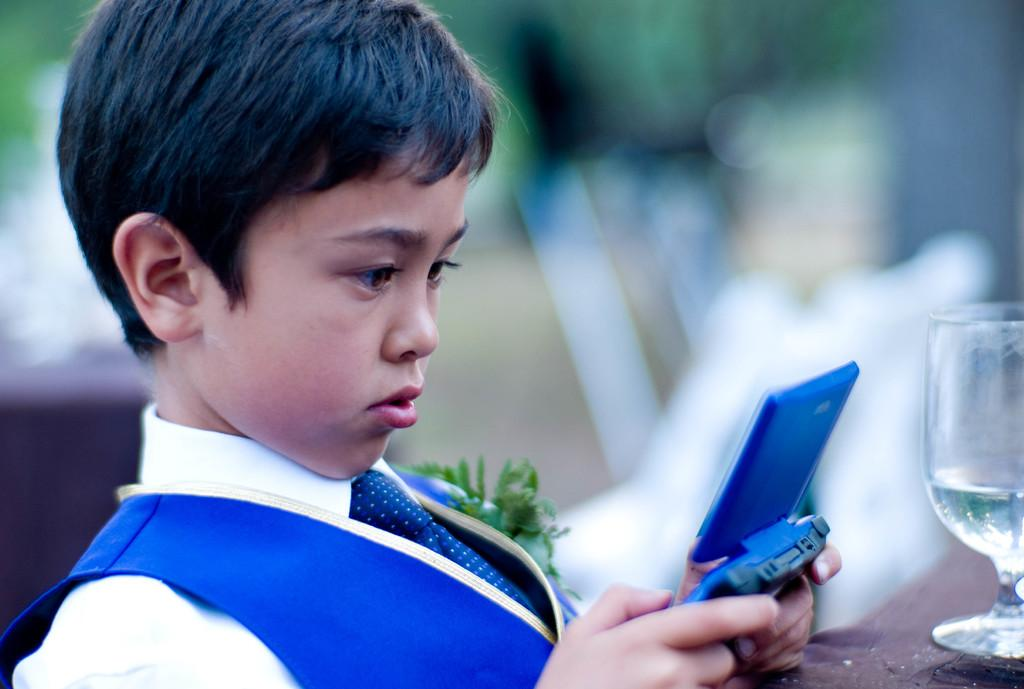Who is the main subject in the image? There is a boy in the center of the image. What is the boy holding in the image? The boy is holding a mobile phone. What can be seen on the right side of the image? There is a glass tumbler on the right side of the image. Where is the glass tumbler placed? The glass tumbler is placed on a table. What type of prose is the boy reading from the mobile phone in the image? There is no indication in the image that the boy is reading any prose from the mobile phone. What is the error in the image? There is no error present in the image. 